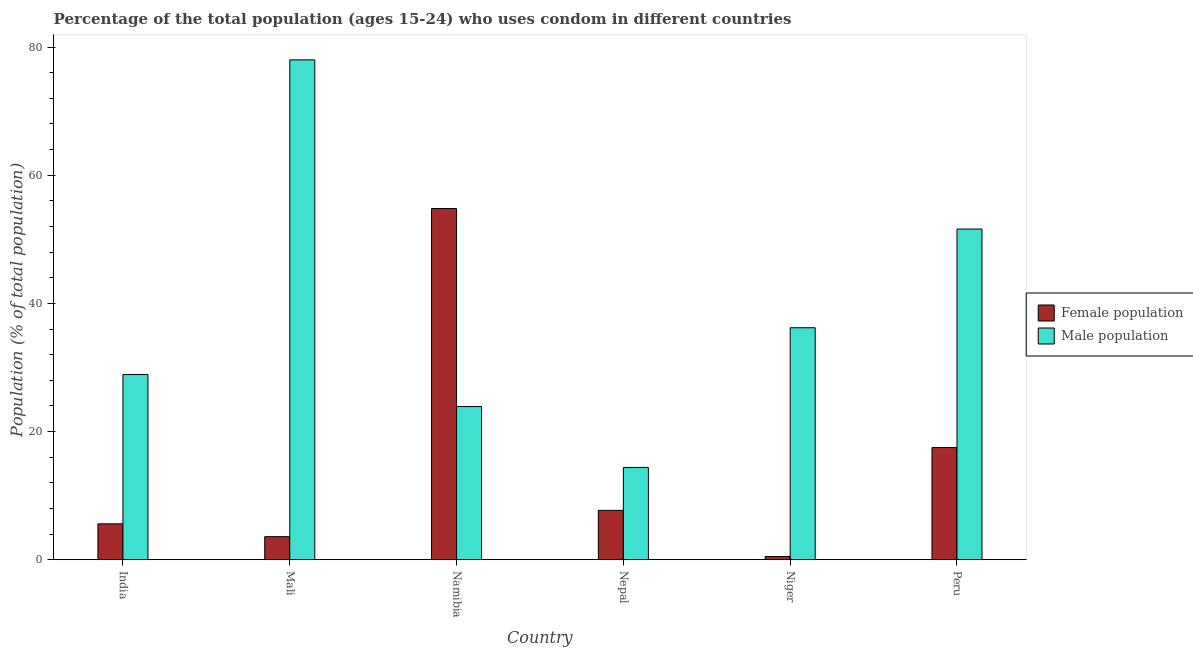What is the label of the 3rd group of bars from the left?
Keep it short and to the point. Namibia. What is the male population in India?
Provide a succinct answer. 28.9. Across all countries, what is the maximum male population?
Offer a terse response. 78. Across all countries, what is the minimum female population?
Provide a short and direct response. 0.5. In which country was the male population maximum?
Provide a short and direct response. Mali. In which country was the male population minimum?
Give a very brief answer. Nepal. What is the total female population in the graph?
Ensure brevity in your answer.  89.7. What is the difference between the male population in Namibia and that in Peru?
Offer a very short reply. -27.7. What is the difference between the male population in Mali and the female population in Nepal?
Provide a short and direct response. 70.3. What is the average female population per country?
Make the answer very short. 14.95. What is the difference between the male population and female population in Niger?
Make the answer very short. 35.7. What is the ratio of the female population in India to that in Peru?
Provide a succinct answer. 0.32. What is the difference between the highest and the second highest male population?
Provide a short and direct response. 26.4. What is the difference between the highest and the lowest male population?
Your answer should be compact. 63.6. What does the 1st bar from the left in Niger represents?
Your response must be concise. Female population. What does the 1st bar from the right in Nepal represents?
Your answer should be very brief. Male population. How many bars are there?
Your answer should be compact. 12. Are all the bars in the graph horizontal?
Offer a very short reply. No. How many countries are there in the graph?
Offer a terse response. 6. Does the graph contain grids?
Give a very brief answer. No. How are the legend labels stacked?
Keep it short and to the point. Vertical. What is the title of the graph?
Your response must be concise. Percentage of the total population (ages 15-24) who uses condom in different countries. Does "Forest land" appear as one of the legend labels in the graph?
Provide a short and direct response. No. What is the label or title of the X-axis?
Offer a terse response. Country. What is the label or title of the Y-axis?
Make the answer very short. Population (% of total population) . What is the Population (% of total population)  of Female population in India?
Your answer should be very brief. 5.6. What is the Population (% of total population)  of Male population in India?
Keep it short and to the point. 28.9. What is the Population (% of total population)  of Female population in Mali?
Provide a short and direct response. 3.6. What is the Population (% of total population)  in Male population in Mali?
Keep it short and to the point. 78. What is the Population (% of total population)  in Female population in Namibia?
Your answer should be compact. 54.8. What is the Population (% of total population)  in Male population in Namibia?
Ensure brevity in your answer.  23.9. What is the Population (% of total population)  of Female population in Niger?
Keep it short and to the point. 0.5. What is the Population (% of total population)  in Male population in Niger?
Offer a very short reply. 36.2. What is the Population (% of total population)  of Female population in Peru?
Your answer should be compact. 17.5. What is the Population (% of total population)  in Male population in Peru?
Your response must be concise. 51.6. Across all countries, what is the maximum Population (% of total population)  in Female population?
Make the answer very short. 54.8. Across all countries, what is the minimum Population (% of total population)  in Female population?
Your answer should be very brief. 0.5. What is the total Population (% of total population)  of Female population in the graph?
Make the answer very short. 89.7. What is the total Population (% of total population)  of Male population in the graph?
Your response must be concise. 233. What is the difference between the Population (% of total population)  in Male population in India and that in Mali?
Offer a very short reply. -49.1. What is the difference between the Population (% of total population)  in Female population in India and that in Namibia?
Offer a terse response. -49.2. What is the difference between the Population (% of total population)  in Male population in India and that in Nepal?
Your answer should be very brief. 14.5. What is the difference between the Population (% of total population)  of Male population in India and that in Peru?
Make the answer very short. -22.7. What is the difference between the Population (% of total population)  of Female population in Mali and that in Namibia?
Your response must be concise. -51.2. What is the difference between the Population (% of total population)  of Male population in Mali and that in Namibia?
Offer a terse response. 54.1. What is the difference between the Population (% of total population)  of Male population in Mali and that in Nepal?
Provide a short and direct response. 63.6. What is the difference between the Population (% of total population)  of Male population in Mali and that in Niger?
Your response must be concise. 41.8. What is the difference between the Population (% of total population)  in Female population in Mali and that in Peru?
Your answer should be very brief. -13.9. What is the difference between the Population (% of total population)  in Male population in Mali and that in Peru?
Offer a very short reply. 26.4. What is the difference between the Population (% of total population)  in Female population in Namibia and that in Nepal?
Provide a succinct answer. 47.1. What is the difference between the Population (% of total population)  of Female population in Namibia and that in Niger?
Keep it short and to the point. 54.3. What is the difference between the Population (% of total population)  in Male population in Namibia and that in Niger?
Give a very brief answer. -12.3. What is the difference between the Population (% of total population)  of Female population in Namibia and that in Peru?
Your answer should be compact. 37.3. What is the difference between the Population (% of total population)  in Male population in Namibia and that in Peru?
Make the answer very short. -27.7. What is the difference between the Population (% of total population)  of Female population in Nepal and that in Niger?
Keep it short and to the point. 7.2. What is the difference between the Population (% of total population)  in Male population in Nepal and that in Niger?
Make the answer very short. -21.8. What is the difference between the Population (% of total population)  of Male population in Nepal and that in Peru?
Your answer should be compact. -37.2. What is the difference between the Population (% of total population)  of Male population in Niger and that in Peru?
Provide a succinct answer. -15.4. What is the difference between the Population (% of total population)  in Female population in India and the Population (% of total population)  in Male population in Mali?
Give a very brief answer. -72.4. What is the difference between the Population (% of total population)  of Female population in India and the Population (% of total population)  of Male population in Namibia?
Your answer should be very brief. -18.3. What is the difference between the Population (% of total population)  in Female population in India and the Population (% of total population)  in Male population in Niger?
Provide a succinct answer. -30.6. What is the difference between the Population (% of total population)  in Female population in India and the Population (% of total population)  in Male population in Peru?
Your answer should be compact. -46. What is the difference between the Population (% of total population)  of Female population in Mali and the Population (% of total population)  of Male population in Namibia?
Your answer should be compact. -20.3. What is the difference between the Population (% of total population)  of Female population in Mali and the Population (% of total population)  of Male population in Niger?
Make the answer very short. -32.6. What is the difference between the Population (% of total population)  in Female population in Mali and the Population (% of total population)  in Male population in Peru?
Your answer should be compact. -48. What is the difference between the Population (% of total population)  in Female population in Namibia and the Population (% of total population)  in Male population in Nepal?
Your answer should be very brief. 40.4. What is the difference between the Population (% of total population)  in Female population in Namibia and the Population (% of total population)  in Male population in Niger?
Your response must be concise. 18.6. What is the difference between the Population (% of total population)  in Female population in Nepal and the Population (% of total population)  in Male population in Niger?
Offer a terse response. -28.5. What is the difference between the Population (% of total population)  in Female population in Nepal and the Population (% of total population)  in Male population in Peru?
Ensure brevity in your answer.  -43.9. What is the difference between the Population (% of total population)  of Female population in Niger and the Population (% of total population)  of Male population in Peru?
Give a very brief answer. -51.1. What is the average Population (% of total population)  of Female population per country?
Your answer should be very brief. 14.95. What is the average Population (% of total population)  in Male population per country?
Offer a terse response. 38.83. What is the difference between the Population (% of total population)  of Female population and Population (% of total population)  of Male population in India?
Make the answer very short. -23.3. What is the difference between the Population (% of total population)  in Female population and Population (% of total population)  in Male population in Mali?
Keep it short and to the point. -74.4. What is the difference between the Population (% of total population)  of Female population and Population (% of total population)  of Male population in Namibia?
Offer a very short reply. 30.9. What is the difference between the Population (% of total population)  of Female population and Population (% of total population)  of Male population in Niger?
Make the answer very short. -35.7. What is the difference between the Population (% of total population)  of Female population and Population (% of total population)  of Male population in Peru?
Make the answer very short. -34.1. What is the ratio of the Population (% of total population)  of Female population in India to that in Mali?
Your answer should be compact. 1.56. What is the ratio of the Population (% of total population)  in Male population in India to that in Mali?
Your answer should be very brief. 0.37. What is the ratio of the Population (% of total population)  of Female population in India to that in Namibia?
Make the answer very short. 0.1. What is the ratio of the Population (% of total population)  in Male population in India to that in Namibia?
Keep it short and to the point. 1.21. What is the ratio of the Population (% of total population)  of Female population in India to that in Nepal?
Provide a short and direct response. 0.73. What is the ratio of the Population (% of total population)  in Male population in India to that in Nepal?
Your response must be concise. 2.01. What is the ratio of the Population (% of total population)  in Female population in India to that in Niger?
Offer a terse response. 11.2. What is the ratio of the Population (% of total population)  of Male population in India to that in Niger?
Offer a very short reply. 0.8. What is the ratio of the Population (% of total population)  in Female population in India to that in Peru?
Make the answer very short. 0.32. What is the ratio of the Population (% of total population)  of Male population in India to that in Peru?
Make the answer very short. 0.56. What is the ratio of the Population (% of total population)  of Female population in Mali to that in Namibia?
Keep it short and to the point. 0.07. What is the ratio of the Population (% of total population)  in Male population in Mali to that in Namibia?
Keep it short and to the point. 3.26. What is the ratio of the Population (% of total population)  of Female population in Mali to that in Nepal?
Your response must be concise. 0.47. What is the ratio of the Population (% of total population)  of Male population in Mali to that in Nepal?
Offer a very short reply. 5.42. What is the ratio of the Population (% of total population)  in Male population in Mali to that in Niger?
Your response must be concise. 2.15. What is the ratio of the Population (% of total population)  of Female population in Mali to that in Peru?
Offer a terse response. 0.21. What is the ratio of the Population (% of total population)  in Male population in Mali to that in Peru?
Give a very brief answer. 1.51. What is the ratio of the Population (% of total population)  in Female population in Namibia to that in Nepal?
Provide a short and direct response. 7.12. What is the ratio of the Population (% of total population)  of Male population in Namibia to that in Nepal?
Offer a terse response. 1.66. What is the ratio of the Population (% of total population)  of Female population in Namibia to that in Niger?
Provide a succinct answer. 109.6. What is the ratio of the Population (% of total population)  of Male population in Namibia to that in Niger?
Offer a very short reply. 0.66. What is the ratio of the Population (% of total population)  of Female population in Namibia to that in Peru?
Your response must be concise. 3.13. What is the ratio of the Population (% of total population)  in Male population in Namibia to that in Peru?
Your response must be concise. 0.46. What is the ratio of the Population (% of total population)  of Male population in Nepal to that in Niger?
Your answer should be very brief. 0.4. What is the ratio of the Population (% of total population)  in Female population in Nepal to that in Peru?
Make the answer very short. 0.44. What is the ratio of the Population (% of total population)  of Male population in Nepal to that in Peru?
Your response must be concise. 0.28. What is the ratio of the Population (% of total population)  of Female population in Niger to that in Peru?
Offer a very short reply. 0.03. What is the ratio of the Population (% of total population)  of Male population in Niger to that in Peru?
Offer a very short reply. 0.7. What is the difference between the highest and the second highest Population (% of total population)  in Female population?
Your response must be concise. 37.3. What is the difference between the highest and the second highest Population (% of total population)  in Male population?
Your answer should be compact. 26.4. What is the difference between the highest and the lowest Population (% of total population)  in Female population?
Give a very brief answer. 54.3. What is the difference between the highest and the lowest Population (% of total population)  in Male population?
Provide a short and direct response. 63.6. 